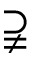Convert formula to latex. <formula><loc_0><loc_0><loc_500><loc_500>\supsetneqq</formula> 